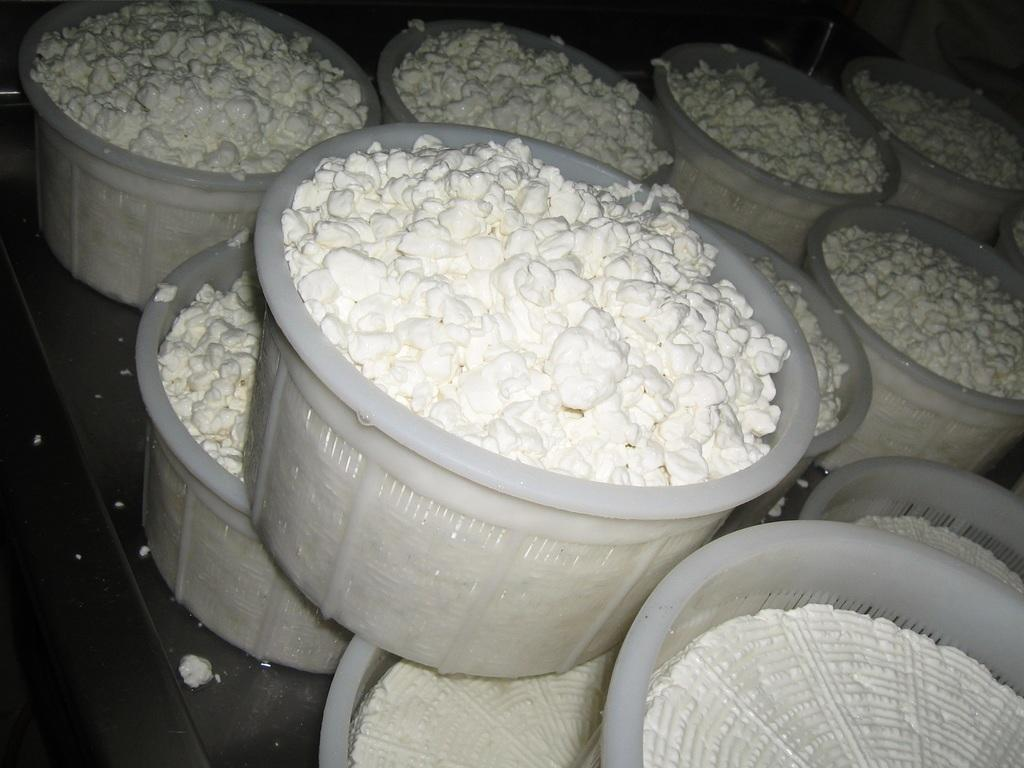What is the color of the food item in the image? The food item in the image is white. How are the food items arranged in the image? The food items are present in different containers. What is the color of the surface on which the containers are placed? The containers are placed on a black surface. What type of amusement can be seen in the image? There is no amusement present in the image; it features a white food item in different containers on a black surface. How does the cannon twist in the image? There is no cannon present in the image, and therefore no twisting can be observed. 